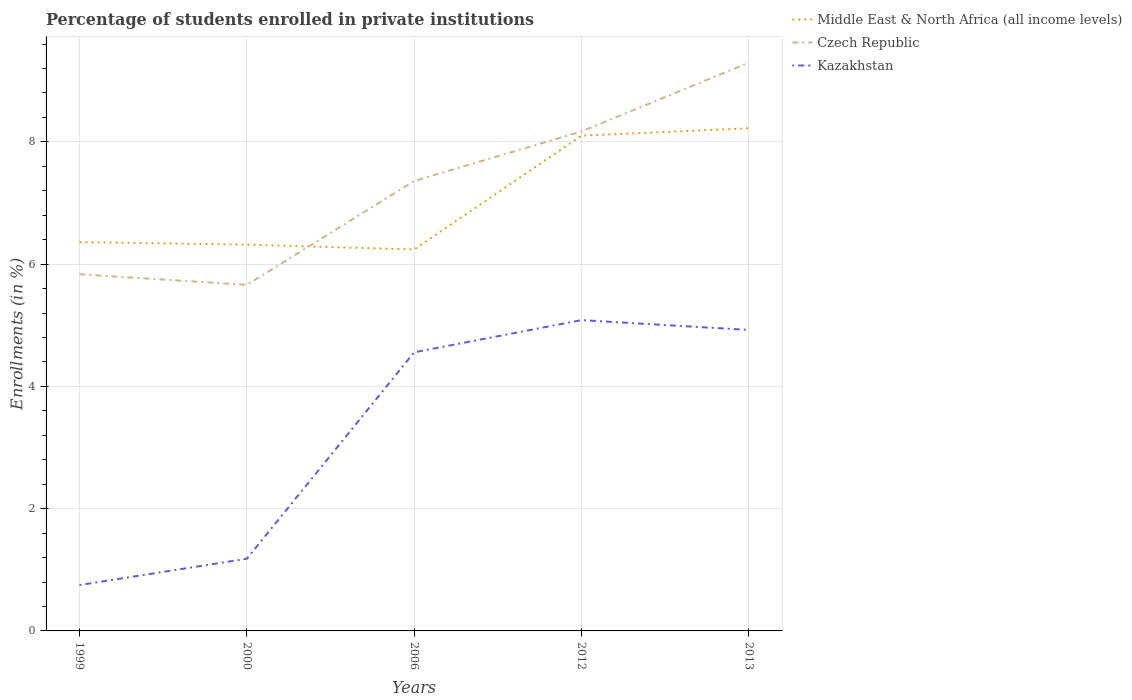How many different coloured lines are there?
Your answer should be compact. 3. Is the number of lines equal to the number of legend labels?
Your answer should be very brief. Yes. Across all years, what is the maximum percentage of trained teachers in Kazakhstan?
Keep it short and to the point. 0.75. In which year was the percentage of trained teachers in Middle East & North Africa (all income levels) maximum?
Provide a succinct answer. 2006. What is the total percentage of trained teachers in Middle East & North Africa (all income levels) in the graph?
Provide a succinct answer. -1.86. What is the difference between the highest and the second highest percentage of trained teachers in Kazakhstan?
Your answer should be compact. 4.33. What is the difference between the highest and the lowest percentage of trained teachers in Middle East & North Africa (all income levels)?
Make the answer very short. 2. Is the percentage of trained teachers in Middle East & North Africa (all income levels) strictly greater than the percentage of trained teachers in Kazakhstan over the years?
Keep it short and to the point. No. What is the difference between two consecutive major ticks on the Y-axis?
Provide a succinct answer. 2. Are the values on the major ticks of Y-axis written in scientific E-notation?
Offer a terse response. No. Where does the legend appear in the graph?
Offer a very short reply. Top right. How many legend labels are there?
Provide a succinct answer. 3. How are the legend labels stacked?
Offer a very short reply. Vertical. What is the title of the graph?
Ensure brevity in your answer.  Percentage of students enrolled in private institutions. What is the label or title of the X-axis?
Provide a succinct answer. Years. What is the label or title of the Y-axis?
Your response must be concise. Enrollments (in %). What is the Enrollments (in %) in Middle East & North Africa (all income levels) in 1999?
Your answer should be compact. 6.36. What is the Enrollments (in %) in Czech Republic in 1999?
Ensure brevity in your answer.  5.83. What is the Enrollments (in %) in Kazakhstan in 1999?
Offer a very short reply. 0.75. What is the Enrollments (in %) in Middle East & North Africa (all income levels) in 2000?
Provide a succinct answer. 6.32. What is the Enrollments (in %) in Czech Republic in 2000?
Give a very brief answer. 5.66. What is the Enrollments (in %) in Kazakhstan in 2000?
Keep it short and to the point. 1.18. What is the Enrollments (in %) of Middle East & North Africa (all income levels) in 2006?
Make the answer very short. 6.24. What is the Enrollments (in %) in Czech Republic in 2006?
Offer a very short reply. 7.36. What is the Enrollments (in %) of Kazakhstan in 2006?
Provide a succinct answer. 4.56. What is the Enrollments (in %) of Middle East & North Africa (all income levels) in 2012?
Provide a short and direct response. 8.1. What is the Enrollments (in %) in Czech Republic in 2012?
Give a very brief answer. 8.17. What is the Enrollments (in %) of Kazakhstan in 2012?
Ensure brevity in your answer.  5.08. What is the Enrollments (in %) in Middle East & North Africa (all income levels) in 2013?
Your answer should be very brief. 8.22. What is the Enrollments (in %) of Czech Republic in 2013?
Your answer should be compact. 9.29. What is the Enrollments (in %) of Kazakhstan in 2013?
Provide a short and direct response. 4.92. Across all years, what is the maximum Enrollments (in %) of Middle East & North Africa (all income levels)?
Your answer should be compact. 8.22. Across all years, what is the maximum Enrollments (in %) in Czech Republic?
Offer a very short reply. 9.29. Across all years, what is the maximum Enrollments (in %) in Kazakhstan?
Give a very brief answer. 5.08. Across all years, what is the minimum Enrollments (in %) in Middle East & North Africa (all income levels)?
Provide a succinct answer. 6.24. Across all years, what is the minimum Enrollments (in %) of Czech Republic?
Your answer should be very brief. 5.66. Across all years, what is the minimum Enrollments (in %) of Kazakhstan?
Offer a very short reply. 0.75. What is the total Enrollments (in %) of Middle East & North Africa (all income levels) in the graph?
Offer a terse response. 35.24. What is the total Enrollments (in %) in Czech Republic in the graph?
Ensure brevity in your answer.  36.32. What is the total Enrollments (in %) of Kazakhstan in the graph?
Provide a short and direct response. 16.5. What is the difference between the Enrollments (in %) in Middle East & North Africa (all income levels) in 1999 and that in 2000?
Offer a very short reply. 0.04. What is the difference between the Enrollments (in %) of Czech Republic in 1999 and that in 2000?
Keep it short and to the point. 0.17. What is the difference between the Enrollments (in %) in Kazakhstan in 1999 and that in 2000?
Your response must be concise. -0.43. What is the difference between the Enrollments (in %) of Middle East & North Africa (all income levels) in 1999 and that in 2006?
Make the answer very short. 0.12. What is the difference between the Enrollments (in %) in Czech Republic in 1999 and that in 2006?
Give a very brief answer. -1.52. What is the difference between the Enrollments (in %) in Kazakhstan in 1999 and that in 2006?
Your response must be concise. -3.81. What is the difference between the Enrollments (in %) in Middle East & North Africa (all income levels) in 1999 and that in 2012?
Make the answer very short. -1.74. What is the difference between the Enrollments (in %) of Czech Republic in 1999 and that in 2012?
Provide a succinct answer. -2.33. What is the difference between the Enrollments (in %) in Kazakhstan in 1999 and that in 2012?
Your answer should be very brief. -4.33. What is the difference between the Enrollments (in %) in Middle East & North Africa (all income levels) in 1999 and that in 2013?
Make the answer very short. -1.86. What is the difference between the Enrollments (in %) of Czech Republic in 1999 and that in 2013?
Ensure brevity in your answer.  -3.46. What is the difference between the Enrollments (in %) of Kazakhstan in 1999 and that in 2013?
Make the answer very short. -4.17. What is the difference between the Enrollments (in %) of Middle East & North Africa (all income levels) in 2000 and that in 2006?
Give a very brief answer. 0.08. What is the difference between the Enrollments (in %) of Czech Republic in 2000 and that in 2006?
Make the answer very short. -1.7. What is the difference between the Enrollments (in %) in Kazakhstan in 2000 and that in 2006?
Your answer should be very brief. -3.38. What is the difference between the Enrollments (in %) in Middle East & North Africa (all income levels) in 2000 and that in 2012?
Provide a succinct answer. -1.78. What is the difference between the Enrollments (in %) in Czech Republic in 2000 and that in 2012?
Offer a very short reply. -2.51. What is the difference between the Enrollments (in %) in Kazakhstan in 2000 and that in 2012?
Keep it short and to the point. -3.9. What is the difference between the Enrollments (in %) in Middle East & North Africa (all income levels) in 2000 and that in 2013?
Provide a succinct answer. -1.9. What is the difference between the Enrollments (in %) in Czech Republic in 2000 and that in 2013?
Provide a short and direct response. -3.63. What is the difference between the Enrollments (in %) of Kazakhstan in 2000 and that in 2013?
Make the answer very short. -3.74. What is the difference between the Enrollments (in %) in Middle East & North Africa (all income levels) in 2006 and that in 2012?
Your answer should be very brief. -1.86. What is the difference between the Enrollments (in %) of Czech Republic in 2006 and that in 2012?
Your answer should be compact. -0.81. What is the difference between the Enrollments (in %) of Kazakhstan in 2006 and that in 2012?
Offer a very short reply. -0.53. What is the difference between the Enrollments (in %) of Middle East & North Africa (all income levels) in 2006 and that in 2013?
Provide a succinct answer. -1.98. What is the difference between the Enrollments (in %) in Czech Republic in 2006 and that in 2013?
Offer a very short reply. -1.93. What is the difference between the Enrollments (in %) of Kazakhstan in 2006 and that in 2013?
Your answer should be compact. -0.37. What is the difference between the Enrollments (in %) of Middle East & North Africa (all income levels) in 2012 and that in 2013?
Provide a succinct answer. -0.12. What is the difference between the Enrollments (in %) of Czech Republic in 2012 and that in 2013?
Ensure brevity in your answer.  -1.12. What is the difference between the Enrollments (in %) of Kazakhstan in 2012 and that in 2013?
Offer a terse response. 0.16. What is the difference between the Enrollments (in %) of Middle East & North Africa (all income levels) in 1999 and the Enrollments (in %) of Czech Republic in 2000?
Give a very brief answer. 0.7. What is the difference between the Enrollments (in %) of Middle East & North Africa (all income levels) in 1999 and the Enrollments (in %) of Kazakhstan in 2000?
Your answer should be compact. 5.18. What is the difference between the Enrollments (in %) of Czech Republic in 1999 and the Enrollments (in %) of Kazakhstan in 2000?
Give a very brief answer. 4.65. What is the difference between the Enrollments (in %) of Middle East & North Africa (all income levels) in 1999 and the Enrollments (in %) of Czech Republic in 2006?
Make the answer very short. -1. What is the difference between the Enrollments (in %) of Middle East & North Africa (all income levels) in 1999 and the Enrollments (in %) of Kazakhstan in 2006?
Provide a succinct answer. 1.8. What is the difference between the Enrollments (in %) of Czech Republic in 1999 and the Enrollments (in %) of Kazakhstan in 2006?
Your response must be concise. 1.28. What is the difference between the Enrollments (in %) of Middle East & North Africa (all income levels) in 1999 and the Enrollments (in %) of Czech Republic in 2012?
Provide a short and direct response. -1.81. What is the difference between the Enrollments (in %) of Middle East & North Africa (all income levels) in 1999 and the Enrollments (in %) of Kazakhstan in 2012?
Your answer should be compact. 1.28. What is the difference between the Enrollments (in %) of Czech Republic in 1999 and the Enrollments (in %) of Kazakhstan in 2012?
Offer a terse response. 0.75. What is the difference between the Enrollments (in %) in Middle East & North Africa (all income levels) in 1999 and the Enrollments (in %) in Czech Republic in 2013?
Your answer should be very brief. -2.93. What is the difference between the Enrollments (in %) in Middle East & North Africa (all income levels) in 1999 and the Enrollments (in %) in Kazakhstan in 2013?
Offer a terse response. 1.44. What is the difference between the Enrollments (in %) of Czech Republic in 1999 and the Enrollments (in %) of Kazakhstan in 2013?
Your response must be concise. 0.91. What is the difference between the Enrollments (in %) in Middle East & North Africa (all income levels) in 2000 and the Enrollments (in %) in Czech Republic in 2006?
Your response must be concise. -1.04. What is the difference between the Enrollments (in %) of Middle East & North Africa (all income levels) in 2000 and the Enrollments (in %) of Kazakhstan in 2006?
Your response must be concise. 1.76. What is the difference between the Enrollments (in %) of Czech Republic in 2000 and the Enrollments (in %) of Kazakhstan in 2006?
Your answer should be compact. 1.1. What is the difference between the Enrollments (in %) of Middle East & North Africa (all income levels) in 2000 and the Enrollments (in %) of Czech Republic in 2012?
Give a very brief answer. -1.85. What is the difference between the Enrollments (in %) of Middle East & North Africa (all income levels) in 2000 and the Enrollments (in %) of Kazakhstan in 2012?
Provide a short and direct response. 1.24. What is the difference between the Enrollments (in %) of Czech Republic in 2000 and the Enrollments (in %) of Kazakhstan in 2012?
Ensure brevity in your answer.  0.58. What is the difference between the Enrollments (in %) in Middle East & North Africa (all income levels) in 2000 and the Enrollments (in %) in Czech Republic in 2013?
Keep it short and to the point. -2.98. What is the difference between the Enrollments (in %) in Middle East & North Africa (all income levels) in 2000 and the Enrollments (in %) in Kazakhstan in 2013?
Keep it short and to the point. 1.4. What is the difference between the Enrollments (in %) in Czech Republic in 2000 and the Enrollments (in %) in Kazakhstan in 2013?
Your answer should be very brief. 0.74. What is the difference between the Enrollments (in %) of Middle East & North Africa (all income levels) in 2006 and the Enrollments (in %) of Czech Republic in 2012?
Your answer should be very brief. -1.93. What is the difference between the Enrollments (in %) of Middle East & North Africa (all income levels) in 2006 and the Enrollments (in %) of Kazakhstan in 2012?
Provide a short and direct response. 1.16. What is the difference between the Enrollments (in %) in Czech Republic in 2006 and the Enrollments (in %) in Kazakhstan in 2012?
Ensure brevity in your answer.  2.28. What is the difference between the Enrollments (in %) in Middle East & North Africa (all income levels) in 2006 and the Enrollments (in %) in Czech Republic in 2013?
Give a very brief answer. -3.06. What is the difference between the Enrollments (in %) in Middle East & North Africa (all income levels) in 2006 and the Enrollments (in %) in Kazakhstan in 2013?
Your answer should be very brief. 1.32. What is the difference between the Enrollments (in %) of Czech Republic in 2006 and the Enrollments (in %) of Kazakhstan in 2013?
Provide a succinct answer. 2.44. What is the difference between the Enrollments (in %) in Middle East & North Africa (all income levels) in 2012 and the Enrollments (in %) in Czech Republic in 2013?
Give a very brief answer. -1.19. What is the difference between the Enrollments (in %) in Middle East & North Africa (all income levels) in 2012 and the Enrollments (in %) in Kazakhstan in 2013?
Provide a succinct answer. 3.18. What is the difference between the Enrollments (in %) of Czech Republic in 2012 and the Enrollments (in %) of Kazakhstan in 2013?
Offer a very short reply. 3.25. What is the average Enrollments (in %) of Middle East & North Africa (all income levels) per year?
Ensure brevity in your answer.  7.05. What is the average Enrollments (in %) in Czech Republic per year?
Offer a terse response. 7.26. What is the average Enrollments (in %) of Kazakhstan per year?
Make the answer very short. 3.3. In the year 1999, what is the difference between the Enrollments (in %) in Middle East & North Africa (all income levels) and Enrollments (in %) in Czech Republic?
Your answer should be compact. 0.53. In the year 1999, what is the difference between the Enrollments (in %) of Middle East & North Africa (all income levels) and Enrollments (in %) of Kazakhstan?
Make the answer very short. 5.61. In the year 1999, what is the difference between the Enrollments (in %) of Czech Republic and Enrollments (in %) of Kazakhstan?
Keep it short and to the point. 5.08. In the year 2000, what is the difference between the Enrollments (in %) of Middle East & North Africa (all income levels) and Enrollments (in %) of Czech Republic?
Ensure brevity in your answer.  0.66. In the year 2000, what is the difference between the Enrollments (in %) of Middle East & North Africa (all income levels) and Enrollments (in %) of Kazakhstan?
Provide a short and direct response. 5.14. In the year 2000, what is the difference between the Enrollments (in %) of Czech Republic and Enrollments (in %) of Kazakhstan?
Your response must be concise. 4.48. In the year 2006, what is the difference between the Enrollments (in %) of Middle East & North Africa (all income levels) and Enrollments (in %) of Czech Republic?
Make the answer very short. -1.12. In the year 2006, what is the difference between the Enrollments (in %) in Middle East & North Africa (all income levels) and Enrollments (in %) in Kazakhstan?
Your answer should be very brief. 1.68. In the year 2006, what is the difference between the Enrollments (in %) of Czech Republic and Enrollments (in %) of Kazakhstan?
Your answer should be very brief. 2.8. In the year 2012, what is the difference between the Enrollments (in %) of Middle East & North Africa (all income levels) and Enrollments (in %) of Czech Republic?
Your answer should be compact. -0.07. In the year 2012, what is the difference between the Enrollments (in %) of Middle East & North Africa (all income levels) and Enrollments (in %) of Kazakhstan?
Give a very brief answer. 3.02. In the year 2012, what is the difference between the Enrollments (in %) in Czech Republic and Enrollments (in %) in Kazakhstan?
Offer a terse response. 3.09. In the year 2013, what is the difference between the Enrollments (in %) of Middle East & North Africa (all income levels) and Enrollments (in %) of Czech Republic?
Offer a very short reply. -1.07. In the year 2013, what is the difference between the Enrollments (in %) in Middle East & North Africa (all income levels) and Enrollments (in %) in Kazakhstan?
Give a very brief answer. 3.3. In the year 2013, what is the difference between the Enrollments (in %) in Czech Republic and Enrollments (in %) in Kazakhstan?
Give a very brief answer. 4.37. What is the ratio of the Enrollments (in %) of Middle East & North Africa (all income levels) in 1999 to that in 2000?
Your answer should be compact. 1.01. What is the ratio of the Enrollments (in %) of Czech Republic in 1999 to that in 2000?
Your answer should be compact. 1.03. What is the ratio of the Enrollments (in %) of Kazakhstan in 1999 to that in 2000?
Keep it short and to the point. 0.64. What is the ratio of the Enrollments (in %) in Middle East & North Africa (all income levels) in 1999 to that in 2006?
Offer a very short reply. 1.02. What is the ratio of the Enrollments (in %) in Czech Republic in 1999 to that in 2006?
Your answer should be very brief. 0.79. What is the ratio of the Enrollments (in %) in Kazakhstan in 1999 to that in 2006?
Offer a very short reply. 0.16. What is the ratio of the Enrollments (in %) of Middle East & North Africa (all income levels) in 1999 to that in 2012?
Offer a terse response. 0.79. What is the ratio of the Enrollments (in %) in Czech Republic in 1999 to that in 2012?
Offer a very short reply. 0.71. What is the ratio of the Enrollments (in %) in Kazakhstan in 1999 to that in 2012?
Your answer should be compact. 0.15. What is the ratio of the Enrollments (in %) of Middle East & North Africa (all income levels) in 1999 to that in 2013?
Your answer should be very brief. 0.77. What is the ratio of the Enrollments (in %) of Czech Republic in 1999 to that in 2013?
Your answer should be very brief. 0.63. What is the ratio of the Enrollments (in %) of Kazakhstan in 1999 to that in 2013?
Your answer should be compact. 0.15. What is the ratio of the Enrollments (in %) in Middle East & North Africa (all income levels) in 2000 to that in 2006?
Your response must be concise. 1.01. What is the ratio of the Enrollments (in %) in Czech Republic in 2000 to that in 2006?
Offer a terse response. 0.77. What is the ratio of the Enrollments (in %) of Kazakhstan in 2000 to that in 2006?
Offer a very short reply. 0.26. What is the ratio of the Enrollments (in %) of Middle East & North Africa (all income levels) in 2000 to that in 2012?
Provide a succinct answer. 0.78. What is the ratio of the Enrollments (in %) of Czech Republic in 2000 to that in 2012?
Your response must be concise. 0.69. What is the ratio of the Enrollments (in %) of Kazakhstan in 2000 to that in 2012?
Keep it short and to the point. 0.23. What is the ratio of the Enrollments (in %) of Middle East & North Africa (all income levels) in 2000 to that in 2013?
Your answer should be compact. 0.77. What is the ratio of the Enrollments (in %) of Czech Republic in 2000 to that in 2013?
Give a very brief answer. 0.61. What is the ratio of the Enrollments (in %) of Kazakhstan in 2000 to that in 2013?
Your response must be concise. 0.24. What is the ratio of the Enrollments (in %) of Middle East & North Africa (all income levels) in 2006 to that in 2012?
Make the answer very short. 0.77. What is the ratio of the Enrollments (in %) of Czech Republic in 2006 to that in 2012?
Provide a short and direct response. 0.9. What is the ratio of the Enrollments (in %) of Kazakhstan in 2006 to that in 2012?
Provide a short and direct response. 0.9. What is the ratio of the Enrollments (in %) of Middle East & North Africa (all income levels) in 2006 to that in 2013?
Keep it short and to the point. 0.76. What is the ratio of the Enrollments (in %) in Czech Republic in 2006 to that in 2013?
Offer a terse response. 0.79. What is the ratio of the Enrollments (in %) in Kazakhstan in 2006 to that in 2013?
Provide a succinct answer. 0.93. What is the ratio of the Enrollments (in %) in Middle East & North Africa (all income levels) in 2012 to that in 2013?
Keep it short and to the point. 0.99. What is the ratio of the Enrollments (in %) in Czech Republic in 2012 to that in 2013?
Offer a very short reply. 0.88. What is the ratio of the Enrollments (in %) in Kazakhstan in 2012 to that in 2013?
Offer a terse response. 1.03. What is the difference between the highest and the second highest Enrollments (in %) in Middle East & North Africa (all income levels)?
Your answer should be compact. 0.12. What is the difference between the highest and the second highest Enrollments (in %) in Czech Republic?
Your answer should be very brief. 1.12. What is the difference between the highest and the second highest Enrollments (in %) of Kazakhstan?
Make the answer very short. 0.16. What is the difference between the highest and the lowest Enrollments (in %) of Middle East & North Africa (all income levels)?
Offer a very short reply. 1.98. What is the difference between the highest and the lowest Enrollments (in %) of Czech Republic?
Your answer should be very brief. 3.63. What is the difference between the highest and the lowest Enrollments (in %) in Kazakhstan?
Your answer should be compact. 4.33. 